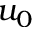Convert formula to latex. <formula><loc_0><loc_0><loc_500><loc_500>u _ { 0 }</formula> 